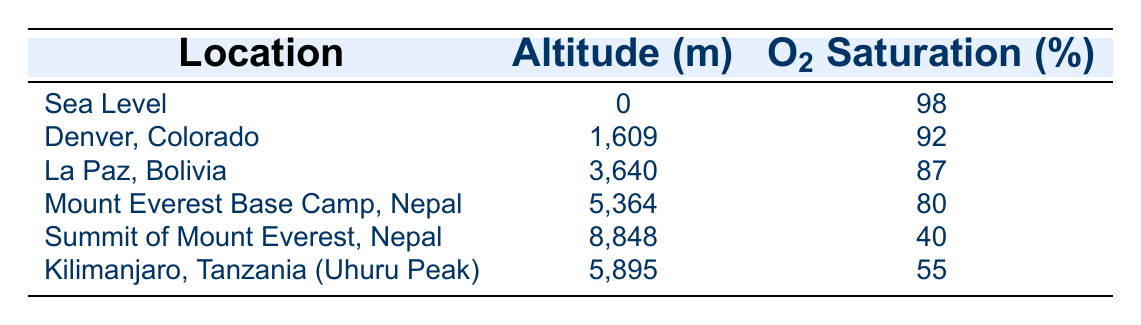What is the oxygen saturation percentage at sea level? From the table, the row for "Sea Level" lists an oxygen saturation percentage of 98%.
Answer: 98% Which location has an oxygen saturation percentage of 87%? Referring to the table, the row labeled "La Paz, Bolivia" shows an oxygen saturation percentage of 87%.
Answer: La Paz, Bolivia What is the difference in oxygen saturation percentage between the summit of Mount Everest and Denver, Colorado? The oxygen saturation percentage at the summit of Mount Everest is 40%, while in Denver, Colorado, it is 92%. The difference is 92 - 40 = 52%.
Answer: 52% Is the oxygen saturation percentage higher in La Paz, Bolivia than in the Mount Everest Base Camp? According to the table, La Paz has an oxygen saturation of 87%, and the Mount Everest Base Camp has 80%. Since 87% is greater than 80%, the statement is true.
Answer: Yes What is the average oxygen saturation percentage of the locations listed in the table? To find the average, sum the oxygen saturation percentages: 98 + 92 + 87 + 80 + 40 + 55 = 452. There are 6 locations, so the average is 452 / 6 = 75.33%.
Answer: 75.33% What altitude has the lowest oxygen saturation percentage, and what is that percentage? The table indicates that the summit of Mount Everest has the lowest oxygen saturation percentage at 40%.
Answer: Summit of Mount Everest, 40% How much lower is the oxygen saturation percentage at Uhuru Peak compared to sea level? The oxygen saturation at Uhuru Peak is 55% and at sea level is 98%. The difference is calculated as 98 - 55 = 43%.
Answer: 43% Is Kilimanjaro, Tanzania (Uhuru Peak) at a higher altitude than Denver, Colorado? The altitude of Kilimanjaro (5,895 meters) is greater than Denver (1,609 meters), confirming that Uhuru Peak is at a higher altitude.
Answer: Yes How does the oxygen saturation percentage at Mount Everest Base Camp compare to that at the summit of Mount Everest? The oxygen saturation at Mount Everest Base Camp is 80%, while at the summit it is 40%. Since 80% is greater than 40%, we conclude that the Base Camp has a higher saturation.
Answer: Higher at Mount Everest Base Camp 